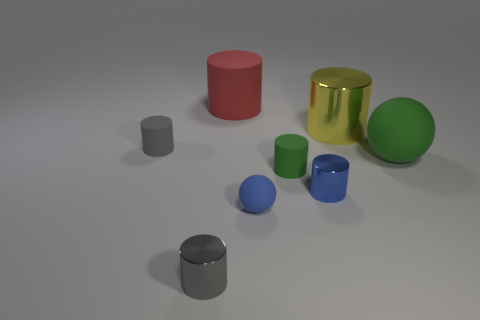There is a big cylinder on the right side of the matte cylinder behind the tiny object that is behind the green matte sphere; what is it made of?
Give a very brief answer. Metal. What number of other things are there of the same size as the red thing?
Provide a short and direct response. 2. Do the tiny ball and the big shiny object have the same color?
Give a very brief answer. No. There is a ball that is on the right side of the small rubber ball in front of the large metallic cylinder; what number of small rubber objects are behind it?
Offer a terse response. 1. There is a blue object that is on the left side of the tiny green object that is in front of the big green thing; what is its material?
Provide a succinct answer. Rubber. Is there a large rubber object of the same shape as the large yellow metal object?
Make the answer very short. Yes. What is the color of the metallic thing that is the same size as the blue shiny cylinder?
Keep it short and to the point. Gray. What number of objects are either small metallic cylinders that are on the left side of the small blue metallic thing or rubber things that are to the left of the large green rubber object?
Your answer should be very brief. 5. How many things are either large green things or gray metallic objects?
Give a very brief answer. 2. There is a metallic cylinder that is both behind the small matte ball and in front of the big green sphere; what size is it?
Your answer should be very brief. Small. 